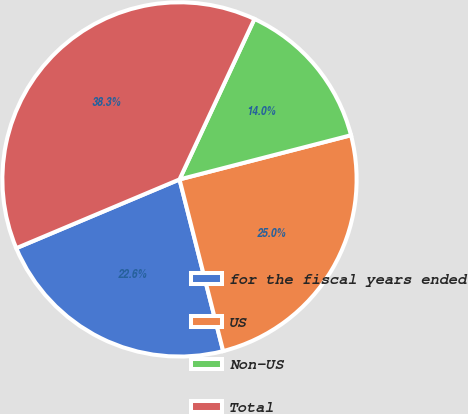<chart> <loc_0><loc_0><loc_500><loc_500><pie_chart><fcel>for the fiscal years ended<fcel>US<fcel>Non-US<fcel>Total<nl><fcel>22.62%<fcel>25.05%<fcel>14.03%<fcel>38.3%<nl></chart> 